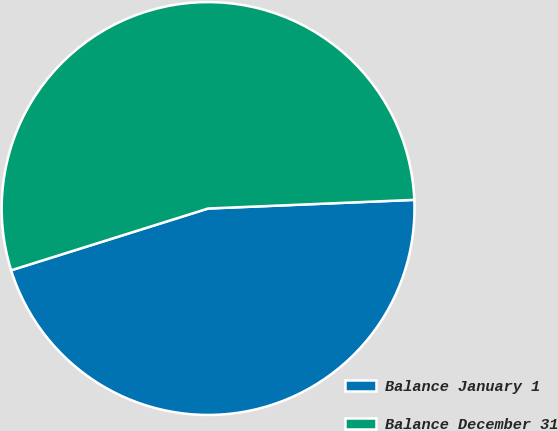<chart> <loc_0><loc_0><loc_500><loc_500><pie_chart><fcel>Balance January 1<fcel>Balance December 31<nl><fcel>45.83%<fcel>54.17%<nl></chart> 